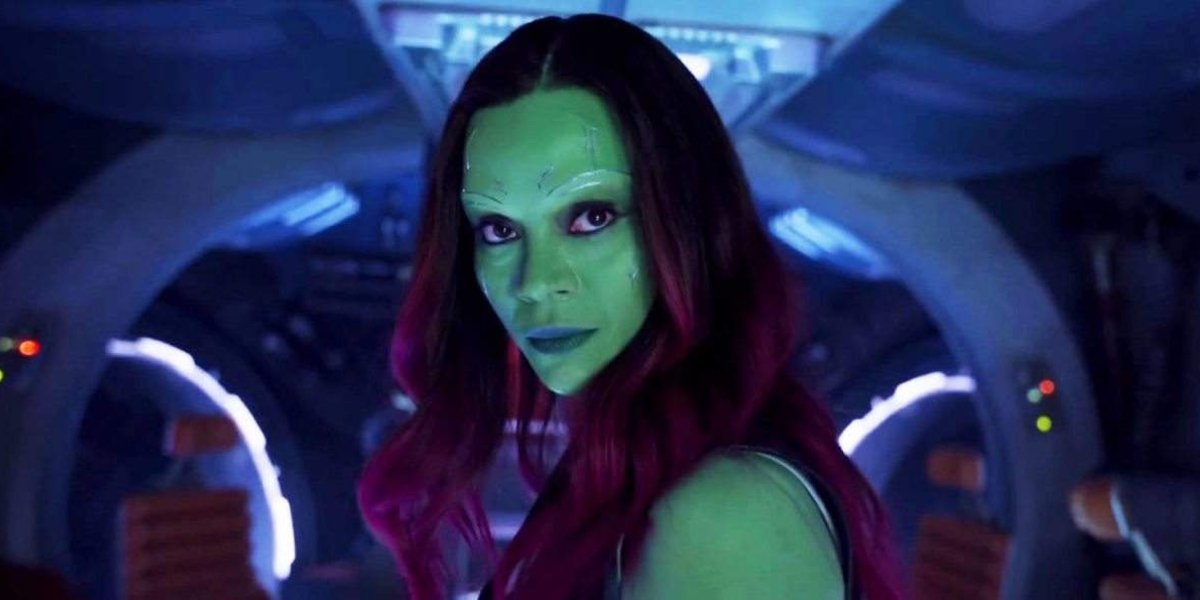Can you describe the main features of this image for me? The image features a character from the movie 'Guardians of the Galaxy'. This character is notable for her distinct green skin tone and vibrant red hair, which stands out against the technological backdrop of a spaceship's interior. She appears focused and stern, suggesting a significant moment or a capture of her complex persona within the film. The lighting in the spaceship gives a haunting mix of blue and orange hues, creating a visually dynamic and otherworldly atmosphere. This character, involved in intricate narratives of conflict and alliance within the film, represents a pivotal figure in the storyline. The detailed depiction hints at her resilience and the sci-fi genre of the movie. 